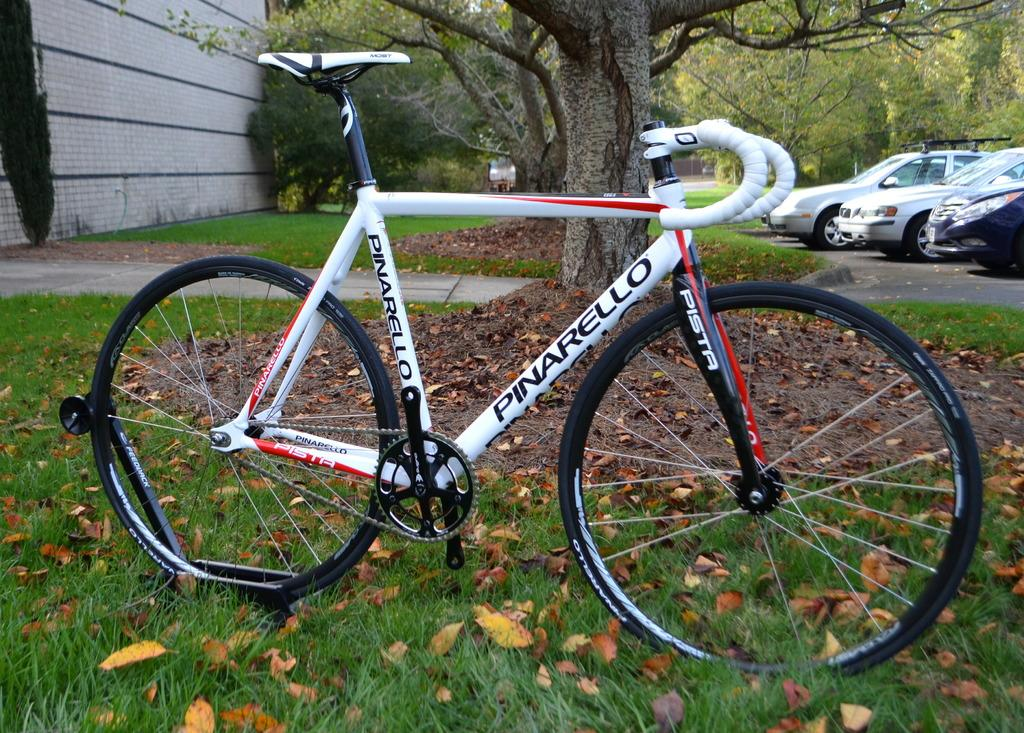What type of vegetation covers the ground in the image? The ground is covered with grass and dried leaves. What can be seen moving or parked in the image? There are vehicles in the image. What type of natural elements are present in the image? There are trees in the image. What type of structure is visible in the image? There is a wall visible in the image. Can you see any quicksand in the image? No, there is no quicksand present in the image. How many cats are sitting on the wall in the image? There are no cats present in the image. 